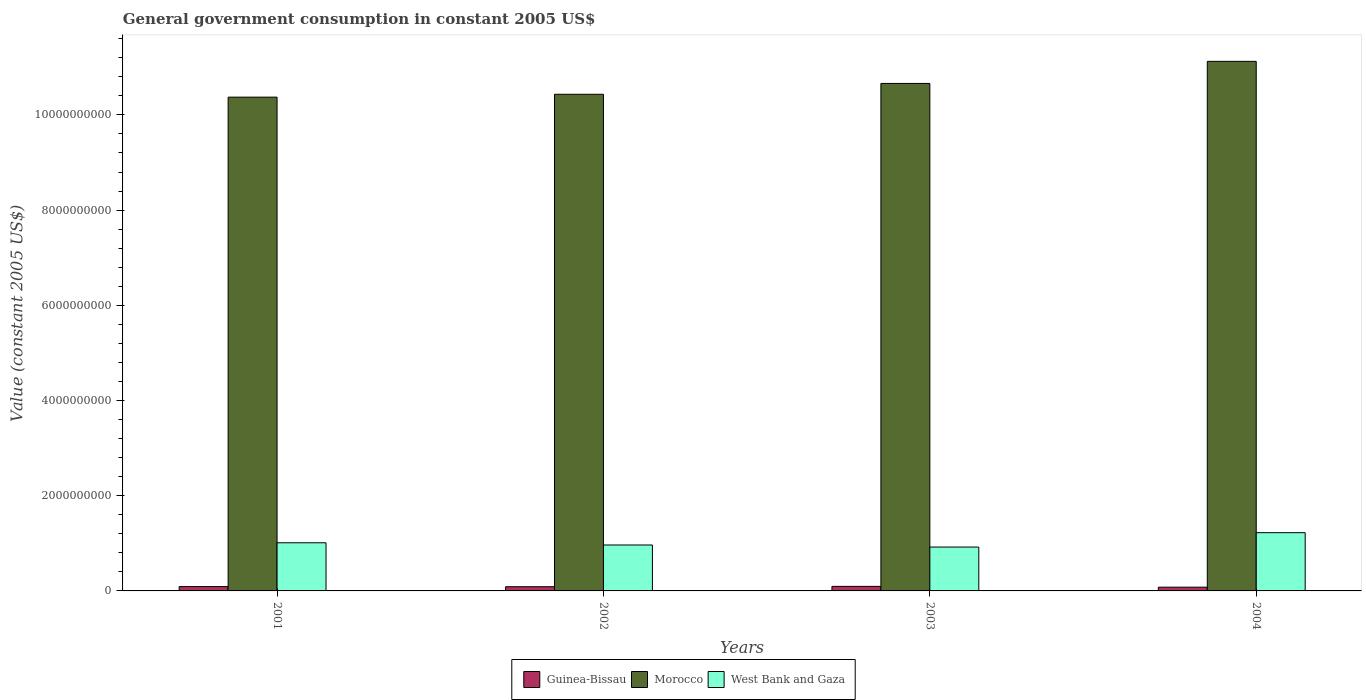How many different coloured bars are there?
Give a very brief answer. 3. How many groups of bars are there?
Make the answer very short. 4. Are the number of bars per tick equal to the number of legend labels?
Make the answer very short. Yes. Are the number of bars on each tick of the X-axis equal?
Your answer should be very brief. Yes. How many bars are there on the 3rd tick from the right?
Keep it short and to the point. 3. What is the label of the 4th group of bars from the left?
Ensure brevity in your answer.  2004. What is the government conusmption in Guinea-Bissau in 2002?
Make the answer very short. 8.84e+07. Across all years, what is the maximum government conusmption in Morocco?
Your answer should be compact. 1.11e+1. Across all years, what is the minimum government conusmption in Morocco?
Your answer should be compact. 1.04e+1. In which year was the government conusmption in Guinea-Bissau minimum?
Ensure brevity in your answer.  2004. What is the total government conusmption in Guinea-Bissau in the graph?
Provide a short and direct response. 3.54e+08. What is the difference between the government conusmption in Guinea-Bissau in 2002 and that in 2004?
Ensure brevity in your answer.  9.87e+06. What is the difference between the government conusmption in Morocco in 2003 and the government conusmption in West Bank and Gaza in 2002?
Offer a very short reply. 9.70e+09. What is the average government conusmption in Guinea-Bissau per year?
Your response must be concise. 8.84e+07. In the year 2002, what is the difference between the government conusmption in Guinea-Bissau and government conusmption in West Bank and Gaza?
Keep it short and to the point. -8.77e+08. In how many years, is the government conusmption in Guinea-Bissau greater than 7200000000 US$?
Provide a short and direct response. 0. What is the ratio of the government conusmption in Morocco in 2002 to that in 2003?
Your answer should be very brief. 0.98. Is the government conusmption in West Bank and Gaza in 2002 less than that in 2003?
Offer a very short reply. No. Is the difference between the government conusmption in Guinea-Bissau in 2002 and 2003 greater than the difference between the government conusmption in West Bank and Gaza in 2002 and 2003?
Your answer should be compact. No. What is the difference between the highest and the second highest government conusmption in Guinea-Bissau?
Your answer should be compact. 4.30e+06. What is the difference between the highest and the lowest government conusmption in Guinea-Bissau?
Keep it short and to the point. 1.69e+07. In how many years, is the government conusmption in West Bank and Gaza greater than the average government conusmption in West Bank and Gaza taken over all years?
Provide a succinct answer. 1. Is the sum of the government conusmption in Morocco in 2002 and 2004 greater than the maximum government conusmption in Guinea-Bissau across all years?
Make the answer very short. Yes. What does the 2nd bar from the left in 2001 represents?
Offer a terse response. Morocco. What does the 2nd bar from the right in 2002 represents?
Offer a very short reply. Morocco. Are the values on the major ticks of Y-axis written in scientific E-notation?
Offer a terse response. No. Does the graph contain grids?
Offer a terse response. No. Where does the legend appear in the graph?
Provide a succinct answer. Bottom center. How many legend labels are there?
Provide a succinct answer. 3. How are the legend labels stacked?
Offer a terse response. Horizontal. What is the title of the graph?
Your answer should be very brief. General government consumption in constant 2005 US$. What is the label or title of the Y-axis?
Offer a terse response. Value (constant 2005 US$). What is the Value (constant 2005 US$) of Guinea-Bissau in 2001?
Keep it short and to the point. 9.12e+07. What is the Value (constant 2005 US$) of Morocco in 2001?
Provide a short and direct response. 1.04e+1. What is the Value (constant 2005 US$) of West Bank and Gaza in 2001?
Offer a very short reply. 1.01e+09. What is the Value (constant 2005 US$) in Guinea-Bissau in 2002?
Offer a very short reply. 8.84e+07. What is the Value (constant 2005 US$) of Morocco in 2002?
Offer a terse response. 1.04e+1. What is the Value (constant 2005 US$) of West Bank and Gaza in 2002?
Your answer should be compact. 9.65e+08. What is the Value (constant 2005 US$) in Guinea-Bissau in 2003?
Provide a succinct answer. 9.55e+07. What is the Value (constant 2005 US$) in Morocco in 2003?
Ensure brevity in your answer.  1.07e+1. What is the Value (constant 2005 US$) of West Bank and Gaza in 2003?
Keep it short and to the point. 9.22e+08. What is the Value (constant 2005 US$) in Guinea-Bissau in 2004?
Offer a very short reply. 7.85e+07. What is the Value (constant 2005 US$) of Morocco in 2004?
Your response must be concise. 1.11e+1. What is the Value (constant 2005 US$) in West Bank and Gaza in 2004?
Your answer should be compact. 1.22e+09. Across all years, what is the maximum Value (constant 2005 US$) of Guinea-Bissau?
Your answer should be compact. 9.55e+07. Across all years, what is the maximum Value (constant 2005 US$) in Morocco?
Give a very brief answer. 1.11e+1. Across all years, what is the maximum Value (constant 2005 US$) of West Bank and Gaza?
Provide a short and direct response. 1.22e+09. Across all years, what is the minimum Value (constant 2005 US$) of Guinea-Bissau?
Your answer should be compact. 7.85e+07. Across all years, what is the minimum Value (constant 2005 US$) in Morocco?
Your answer should be very brief. 1.04e+1. Across all years, what is the minimum Value (constant 2005 US$) of West Bank and Gaza?
Keep it short and to the point. 9.22e+08. What is the total Value (constant 2005 US$) in Guinea-Bissau in the graph?
Provide a short and direct response. 3.54e+08. What is the total Value (constant 2005 US$) in Morocco in the graph?
Give a very brief answer. 4.26e+1. What is the total Value (constant 2005 US$) in West Bank and Gaza in the graph?
Make the answer very short. 4.12e+09. What is the difference between the Value (constant 2005 US$) of Guinea-Bissau in 2001 and that in 2002?
Your answer should be very brief. 2.77e+06. What is the difference between the Value (constant 2005 US$) of Morocco in 2001 and that in 2002?
Provide a short and direct response. -6.02e+07. What is the difference between the Value (constant 2005 US$) in West Bank and Gaza in 2001 and that in 2002?
Offer a very short reply. 4.66e+07. What is the difference between the Value (constant 2005 US$) in Guinea-Bissau in 2001 and that in 2003?
Keep it short and to the point. -4.30e+06. What is the difference between the Value (constant 2005 US$) in Morocco in 2001 and that in 2003?
Provide a succinct answer. -2.88e+08. What is the difference between the Value (constant 2005 US$) of West Bank and Gaza in 2001 and that in 2003?
Ensure brevity in your answer.  9.00e+07. What is the difference between the Value (constant 2005 US$) of Guinea-Bissau in 2001 and that in 2004?
Make the answer very short. 1.26e+07. What is the difference between the Value (constant 2005 US$) in Morocco in 2001 and that in 2004?
Your answer should be compact. -7.52e+08. What is the difference between the Value (constant 2005 US$) of West Bank and Gaza in 2001 and that in 2004?
Your answer should be very brief. -2.12e+08. What is the difference between the Value (constant 2005 US$) of Guinea-Bissau in 2002 and that in 2003?
Make the answer very short. -7.07e+06. What is the difference between the Value (constant 2005 US$) in Morocco in 2002 and that in 2003?
Your answer should be compact. -2.28e+08. What is the difference between the Value (constant 2005 US$) of West Bank and Gaza in 2002 and that in 2003?
Provide a succinct answer. 4.33e+07. What is the difference between the Value (constant 2005 US$) in Guinea-Bissau in 2002 and that in 2004?
Your answer should be compact. 9.87e+06. What is the difference between the Value (constant 2005 US$) of Morocco in 2002 and that in 2004?
Your response must be concise. -6.92e+08. What is the difference between the Value (constant 2005 US$) in West Bank and Gaza in 2002 and that in 2004?
Offer a very short reply. -2.59e+08. What is the difference between the Value (constant 2005 US$) in Guinea-Bissau in 2003 and that in 2004?
Your answer should be compact. 1.69e+07. What is the difference between the Value (constant 2005 US$) of Morocco in 2003 and that in 2004?
Offer a very short reply. -4.64e+08. What is the difference between the Value (constant 2005 US$) in West Bank and Gaza in 2003 and that in 2004?
Offer a very short reply. -3.02e+08. What is the difference between the Value (constant 2005 US$) in Guinea-Bissau in 2001 and the Value (constant 2005 US$) in Morocco in 2002?
Make the answer very short. -1.03e+1. What is the difference between the Value (constant 2005 US$) in Guinea-Bissau in 2001 and the Value (constant 2005 US$) in West Bank and Gaza in 2002?
Make the answer very short. -8.74e+08. What is the difference between the Value (constant 2005 US$) in Morocco in 2001 and the Value (constant 2005 US$) in West Bank and Gaza in 2002?
Provide a short and direct response. 9.41e+09. What is the difference between the Value (constant 2005 US$) of Guinea-Bissau in 2001 and the Value (constant 2005 US$) of Morocco in 2003?
Ensure brevity in your answer.  -1.06e+1. What is the difference between the Value (constant 2005 US$) in Guinea-Bissau in 2001 and the Value (constant 2005 US$) in West Bank and Gaza in 2003?
Offer a very short reply. -8.30e+08. What is the difference between the Value (constant 2005 US$) in Morocco in 2001 and the Value (constant 2005 US$) in West Bank and Gaza in 2003?
Make the answer very short. 9.45e+09. What is the difference between the Value (constant 2005 US$) of Guinea-Bissau in 2001 and the Value (constant 2005 US$) of Morocco in 2004?
Offer a very short reply. -1.10e+1. What is the difference between the Value (constant 2005 US$) in Guinea-Bissau in 2001 and the Value (constant 2005 US$) in West Bank and Gaza in 2004?
Your response must be concise. -1.13e+09. What is the difference between the Value (constant 2005 US$) in Morocco in 2001 and the Value (constant 2005 US$) in West Bank and Gaza in 2004?
Your answer should be compact. 9.15e+09. What is the difference between the Value (constant 2005 US$) in Guinea-Bissau in 2002 and the Value (constant 2005 US$) in Morocco in 2003?
Offer a terse response. -1.06e+1. What is the difference between the Value (constant 2005 US$) in Guinea-Bissau in 2002 and the Value (constant 2005 US$) in West Bank and Gaza in 2003?
Your answer should be very brief. -8.33e+08. What is the difference between the Value (constant 2005 US$) in Morocco in 2002 and the Value (constant 2005 US$) in West Bank and Gaza in 2003?
Your answer should be compact. 9.51e+09. What is the difference between the Value (constant 2005 US$) of Guinea-Bissau in 2002 and the Value (constant 2005 US$) of Morocco in 2004?
Your response must be concise. -1.10e+1. What is the difference between the Value (constant 2005 US$) in Guinea-Bissau in 2002 and the Value (constant 2005 US$) in West Bank and Gaza in 2004?
Provide a succinct answer. -1.14e+09. What is the difference between the Value (constant 2005 US$) in Morocco in 2002 and the Value (constant 2005 US$) in West Bank and Gaza in 2004?
Make the answer very short. 9.21e+09. What is the difference between the Value (constant 2005 US$) in Guinea-Bissau in 2003 and the Value (constant 2005 US$) in Morocco in 2004?
Offer a terse response. -1.10e+1. What is the difference between the Value (constant 2005 US$) in Guinea-Bissau in 2003 and the Value (constant 2005 US$) in West Bank and Gaza in 2004?
Provide a short and direct response. -1.13e+09. What is the difference between the Value (constant 2005 US$) of Morocco in 2003 and the Value (constant 2005 US$) of West Bank and Gaza in 2004?
Ensure brevity in your answer.  9.44e+09. What is the average Value (constant 2005 US$) of Guinea-Bissau per year?
Offer a very short reply. 8.84e+07. What is the average Value (constant 2005 US$) of Morocco per year?
Offer a very short reply. 1.06e+1. What is the average Value (constant 2005 US$) of West Bank and Gaza per year?
Offer a very short reply. 1.03e+09. In the year 2001, what is the difference between the Value (constant 2005 US$) of Guinea-Bissau and Value (constant 2005 US$) of Morocco?
Provide a short and direct response. -1.03e+1. In the year 2001, what is the difference between the Value (constant 2005 US$) in Guinea-Bissau and Value (constant 2005 US$) in West Bank and Gaza?
Your answer should be compact. -9.20e+08. In the year 2001, what is the difference between the Value (constant 2005 US$) of Morocco and Value (constant 2005 US$) of West Bank and Gaza?
Ensure brevity in your answer.  9.36e+09. In the year 2002, what is the difference between the Value (constant 2005 US$) in Guinea-Bissau and Value (constant 2005 US$) in Morocco?
Keep it short and to the point. -1.03e+1. In the year 2002, what is the difference between the Value (constant 2005 US$) in Guinea-Bissau and Value (constant 2005 US$) in West Bank and Gaza?
Provide a succinct answer. -8.77e+08. In the year 2002, what is the difference between the Value (constant 2005 US$) in Morocco and Value (constant 2005 US$) in West Bank and Gaza?
Your answer should be very brief. 9.47e+09. In the year 2003, what is the difference between the Value (constant 2005 US$) of Guinea-Bissau and Value (constant 2005 US$) of Morocco?
Provide a short and direct response. -1.06e+1. In the year 2003, what is the difference between the Value (constant 2005 US$) of Guinea-Bissau and Value (constant 2005 US$) of West Bank and Gaza?
Provide a short and direct response. -8.26e+08. In the year 2003, what is the difference between the Value (constant 2005 US$) of Morocco and Value (constant 2005 US$) of West Bank and Gaza?
Offer a very short reply. 9.74e+09. In the year 2004, what is the difference between the Value (constant 2005 US$) of Guinea-Bissau and Value (constant 2005 US$) of Morocco?
Keep it short and to the point. -1.10e+1. In the year 2004, what is the difference between the Value (constant 2005 US$) of Guinea-Bissau and Value (constant 2005 US$) of West Bank and Gaza?
Provide a short and direct response. -1.15e+09. In the year 2004, what is the difference between the Value (constant 2005 US$) of Morocco and Value (constant 2005 US$) of West Bank and Gaza?
Your answer should be very brief. 9.90e+09. What is the ratio of the Value (constant 2005 US$) of Guinea-Bissau in 2001 to that in 2002?
Offer a terse response. 1.03. What is the ratio of the Value (constant 2005 US$) of West Bank and Gaza in 2001 to that in 2002?
Your answer should be compact. 1.05. What is the ratio of the Value (constant 2005 US$) of Guinea-Bissau in 2001 to that in 2003?
Offer a terse response. 0.95. What is the ratio of the Value (constant 2005 US$) of Morocco in 2001 to that in 2003?
Ensure brevity in your answer.  0.97. What is the ratio of the Value (constant 2005 US$) of West Bank and Gaza in 2001 to that in 2003?
Provide a succinct answer. 1.1. What is the ratio of the Value (constant 2005 US$) of Guinea-Bissau in 2001 to that in 2004?
Give a very brief answer. 1.16. What is the ratio of the Value (constant 2005 US$) of Morocco in 2001 to that in 2004?
Your response must be concise. 0.93. What is the ratio of the Value (constant 2005 US$) in West Bank and Gaza in 2001 to that in 2004?
Offer a very short reply. 0.83. What is the ratio of the Value (constant 2005 US$) in Guinea-Bissau in 2002 to that in 2003?
Offer a terse response. 0.93. What is the ratio of the Value (constant 2005 US$) in Morocco in 2002 to that in 2003?
Your response must be concise. 0.98. What is the ratio of the Value (constant 2005 US$) in West Bank and Gaza in 2002 to that in 2003?
Offer a very short reply. 1.05. What is the ratio of the Value (constant 2005 US$) of Guinea-Bissau in 2002 to that in 2004?
Provide a succinct answer. 1.13. What is the ratio of the Value (constant 2005 US$) in Morocco in 2002 to that in 2004?
Your answer should be very brief. 0.94. What is the ratio of the Value (constant 2005 US$) of West Bank and Gaza in 2002 to that in 2004?
Provide a succinct answer. 0.79. What is the ratio of the Value (constant 2005 US$) of Guinea-Bissau in 2003 to that in 2004?
Ensure brevity in your answer.  1.22. What is the ratio of the Value (constant 2005 US$) of West Bank and Gaza in 2003 to that in 2004?
Keep it short and to the point. 0.75. What is the difference between the highest and the second highest Value (constant 2005 US$) of Guinea-Bissau?
Provide a succinct answer. 4.30e+06. What is the difference between the highest and the second highest Value (constant 2005 US$) in Morocco?
Give a very brief answer. 4.64e+08. What is the difference between the highest and the second highest Value (constant 2005 US$) of West Bank and Gaza?
Offer a terse response. 2.12e+08. What is the difference between the highest and the lowest Value (constant 2005 US$) in Guinea-Bissau?
Ensure brevity in your answer.  1.69e+07. What is the difference between the highest and the lowest Value (constant 2005 US$) in Morocco?
Provide a succinct answer. 7.52e+08. What is the difference between the highest and the lowest Value (constant 2005 US$) in West Bank and Gaza?
Make the answer very short. 3.02e+08. 